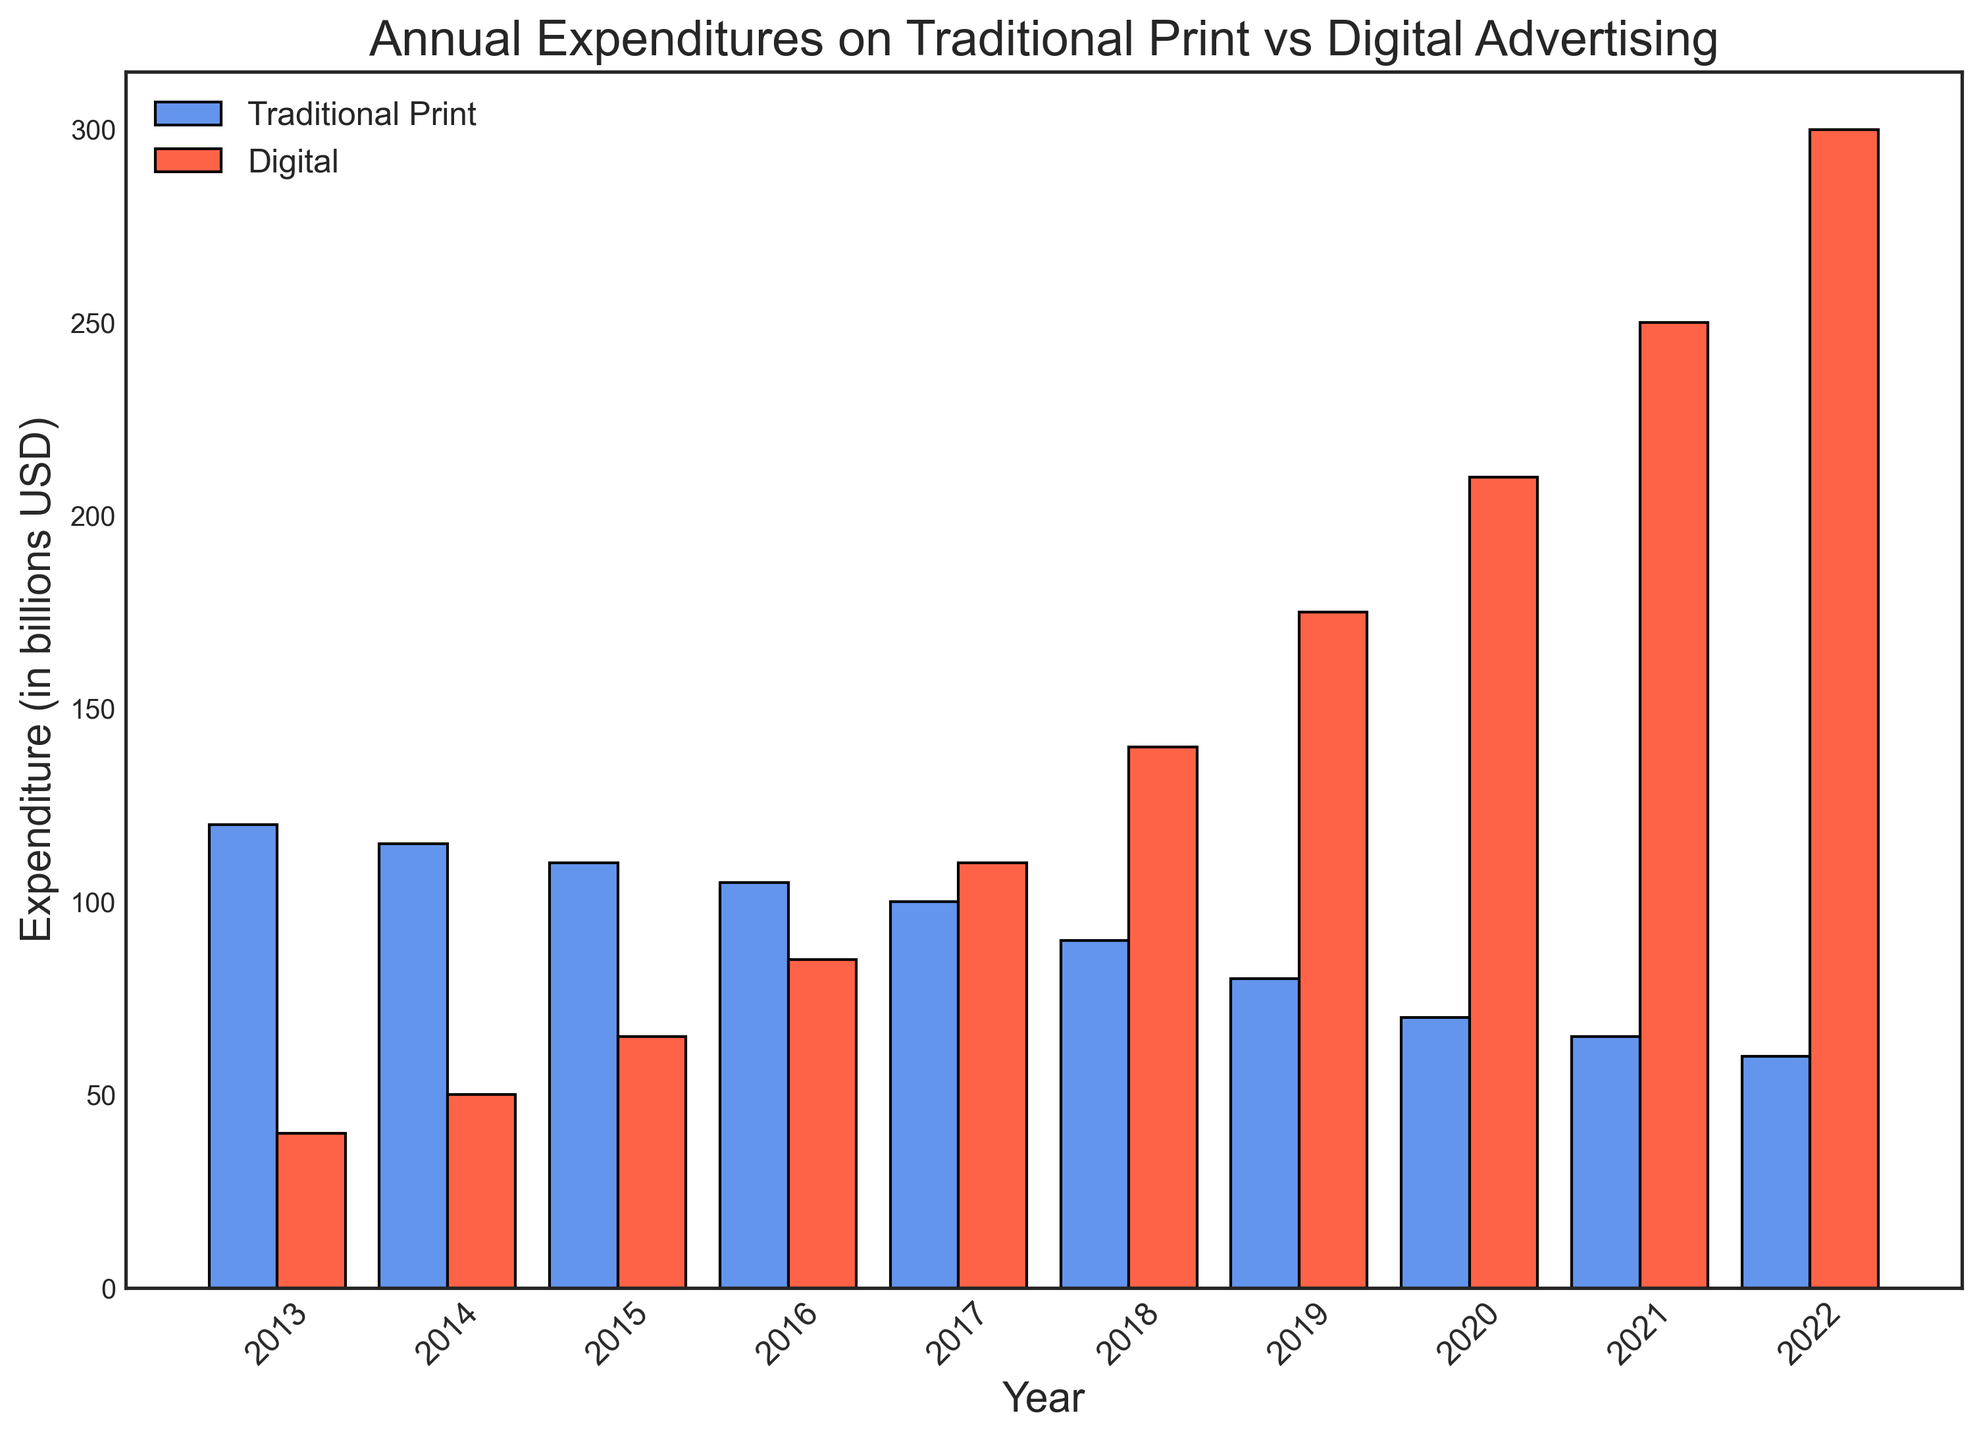Which year had the highest traditional print advertising expenditure? To find the highest traditional print advertising expenditure, look at the height of the blue bars. The tallest blue bar represents 2013, indicating the highest spending.
Answer: 2013 In which year did digital advertising expenditure first surpass traditional print advertising expenditure? Compare the heights of the red and blue bars for each year. 2017 is the first year where the red bar (digital advertising) is taller than the blue bar (traditional print).
Answer: 2017 What is the overall trend in traditional print advertising expenditure from 2013 to 2022? Observe the heights of the blue bars over the years. The blue bars gradually decrease in height from 2013 to 2022, indicating a declining trend.
Answer: Declining Which year saw the greatest increase in digital advertising expenditure compared to the previous year? Compare the height differences of the red bars year by year. The jump from 2021 to 2022 shows the largest increase.
Answer: 2022 By how much did traditional print advertising expenditure decline from 2013 to 2022? Identify the heights of the blue bars in 2013 and 2022. Subtract the 2022 value (60) from the 2013 value (120). The decline is 120 - 60.
Answer: 60 billion USD How much more was spent on digital advertising compared to traditional print advertising in 2022? Observe the heights of the red and blue bars in 2022. The digital expenditure is 300, and the traditional expenditure is 60. Calculate the difference: 300 - 60.
Answer: 240 billion USD What is the average annual expenditure on digital advertising from 2013 to 2022? Add the heights of all the red bars and divide by the number of years (10). The total is 40 + 50 + 65 + 85 + 110 + 140 + 175 + 210 + 250 + 300 = 1425. So the average is 1425 / 10.
Answer: 142.5 billion USD In which year was the difference between traditional print and digital advertising expenditures the smallest? Check the relative heights of the red and blue bars and find the year with the smallest gap. 2014 shows the smallest difference, as the bars are relatively close in height.
Answer: 2014 If you combined the expenditures for both types of advertising, which year had the highest total spending? Add the heights of the red and blue bars for each year and find the maximum. 2022 had the highest combined spending: 60 (traditional) + 300 (digital) = 360.
Answer: 2022 